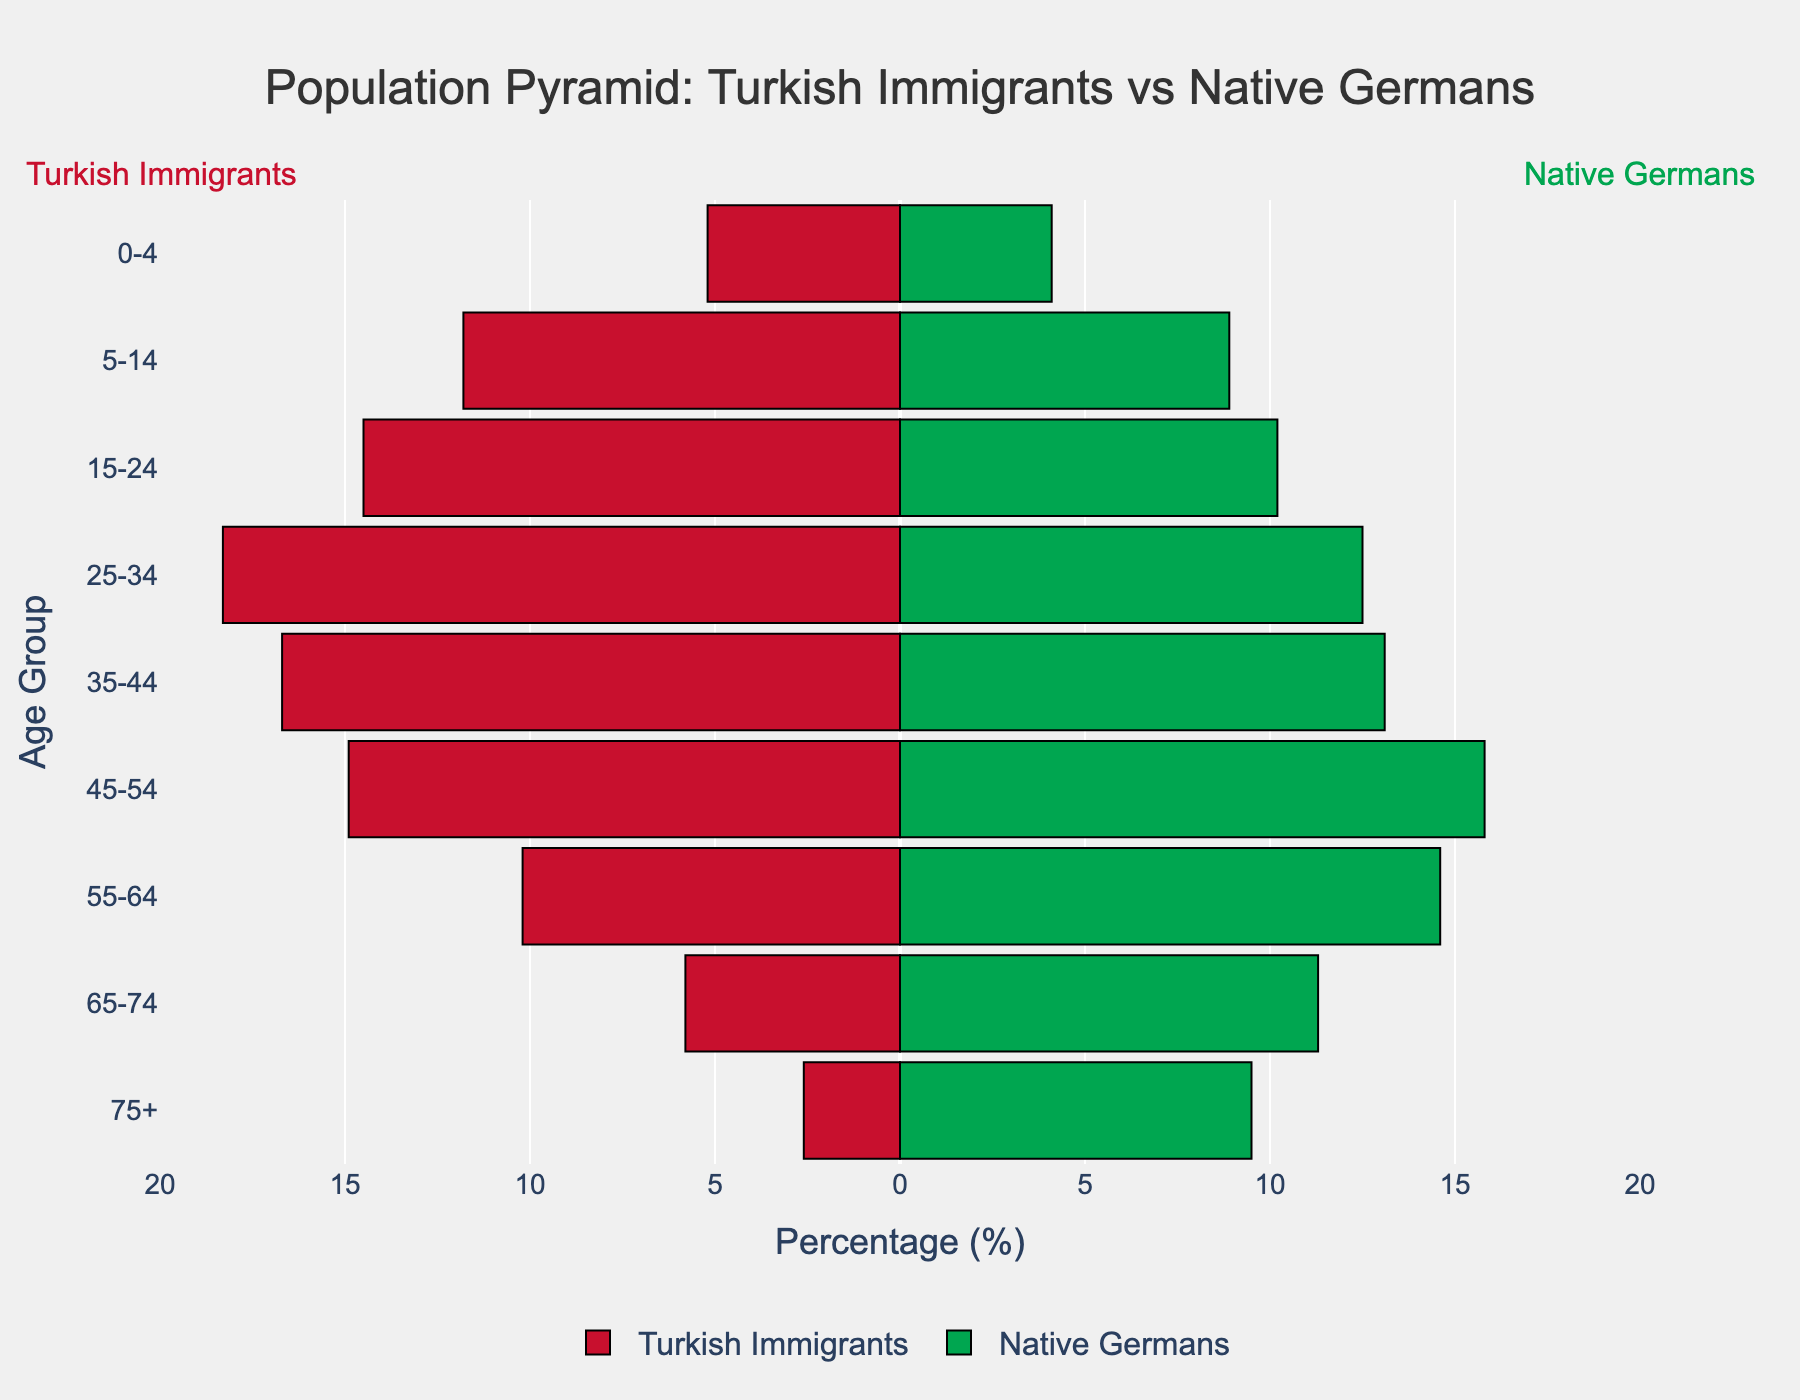What's the total percentage of Turkish immigrants in the age groups 15-24 and 25-34 combined? Combine the percentages: 14.5% for 15-24 and 18.3% for 25-34. Sum them up (14.5 + 18.3).
Answer: 32.8% Which age group has the highest percentage of Turkish immigrants? The highest percentage of Turkish immigrants is in the 25-34 age group (18.3%).
Answer: 25-34 How does the percentage of native Germans age 75+ compare to Turkish immigrants in the same age group? Compare the percentages: native Germans age 75+ are 9.5%, while Turkish immigrants in the same age group are 2.6%.
Answer: Native Germans have a higher percentage What is the difference in percentages of Turkish immigrants and native Germans aged 5-14? Subtract the percentage of native Germans aged 5-14 (8.9%) from Turkish immigrants aged 5-14 (11.8%). (11.8 - 8.9).
Answer: 2.9% Which populations have a higher percentage of people aged 55-64, Turkish immigrants or native Germans? Compare the percentages: Turkish immigrants aged 55-64 are 10.2%, native Germans in the same age group are 14.6%.
Answer: Native Germans What are the age groups where Turkish immigrants have higher percentages than native Germans? Review each age group’s percentages and compare: Turkish immigrants have higher percentages in 0-4, 5-14, 15-24, 25-34, and 35-44 age groups.
Answer: 0-4, 5-14, 15-24, 25-34, 35-44 What is the percentage gap in the 65-74 age group between Turkish immigrants and native Germans? Subtract the percentage of Turkish immigrants aged 65-74 (5.8%) from native Germans in the same age group (11.3%). (11.3 - 5.8).
Answer: 5.5% Which age group of Turkish immigrants has the lowest population percentage? The lowest percentage of Turkish immigrants is in the 75+ age group (2.6%).
Answer: 75+ How does the overall distribution trend of the Turkish immigrant population compare to that of native Germans by age group? Turkish immigrants have a higher percentage in younger age groups (0-44) and significantly lower percentages in older age groups (45+), whereas the native Germans have a relatively balanced distribution with higher percentages in the older age groups (55+).
Answer: Turkish immigrants skew younger, native Germans skew older 